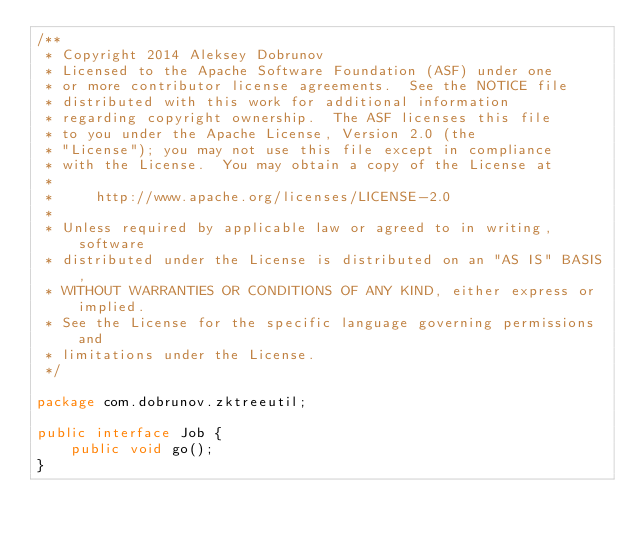Convert code to text. <code><loc_0><loc_0><loc_500><loc_500><_Java_>/**
 * Copyright 2014 Aleksey Dobrunov
 * Licensed to the Apache Software Foundation (ASF) under one
 * or more contributor license agreements.  See the NOTICE file
 * distributed with this work for additional information
 * regarding copyright ownership.  The ASF licenses this file
 * to you under the Apache License, Version 2.0 (the
 * "License"); you may not use this file except in compliance
 * with the License.  You may obtain a copy of the License at
 *
 *     http://www.apache.org/licenses/LICENSE-2.0
 *
 * Unless required by applicable law or agreed to in writing, software
 * distributed under the License is distributed on an "AS IS" BASIS,
 * WITHOUT WARRANTIES OR CONDITIONS OF ANY KIND, either express or implied.
 * See the License for the specific language governing permissions and
 * limitations under the License.
 */

package com.dobrunov.zktreeutil;

public interface Job {
    public void go();
}
</code> 